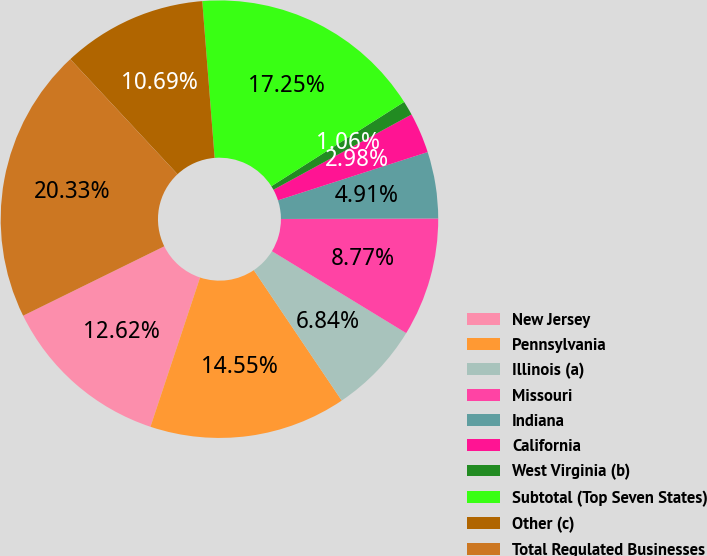<chart> <loc_0><loc_0><loc_500><loc_500><pie_chart><fcel>New Jersey<fcel>Pennsylvania<fcel>Illinois (a)<fcel>Missouri<fcel>Indiana<fcel>California<fcel>West Virginia (b)<fcel>Subtotal (Top Seven States)<fcel>Other (c)<fcel>Total Regulated Businesses<nl><fcel>12.62%<fcel>14.55%<fcel>6.84%<fcel>8.77%<fcel>4.91%<fcel>2.98%<fcel>1.06%<fcel>17.25%<fcel>10.69%<fcel>20.33%<nl></chart> 